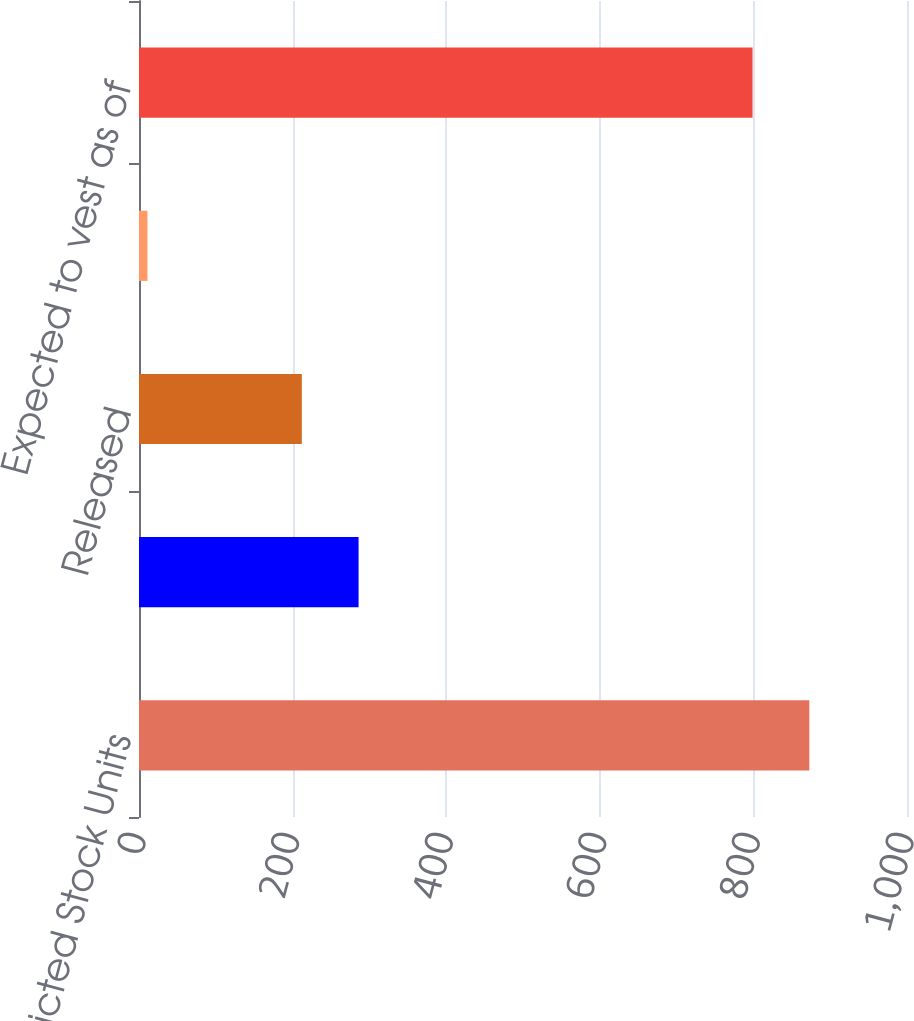Convert chart. <chart><loc_0><loc_0><loc_500><loc_500><bar_chart><fcel>Restricted Stock Units<fcel>Granted<fcel>Released<fcel>Forfeited<fcel>Expected to vest as of<nl><fcel>872.8<fcel>285.9<fcel>212<fcel>11<fcel>798.9<nl></chart> 